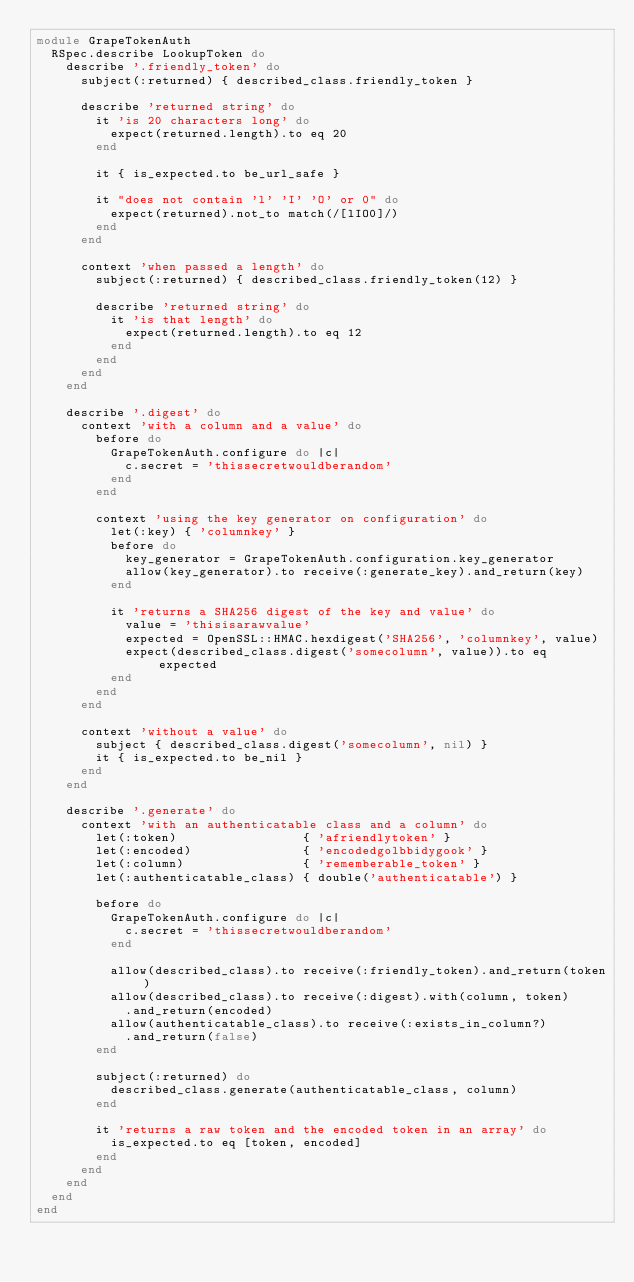Convert code to text. <code><loc_0><loc_0><loc_500><loc_500><_Ruby_>module GrapeTokenAuth
  RSpec.describe LookupToken do
    describe '.friendly_token' do
      subject(:returned) { described_class.friendly_token }

      describe 'returned string' do
        it 'is 20 characters long' do
          expect(returned.length).to eq 20
        end

        it { is_expected.to be_url_safe }

        it "does not contain 'l' 'I' 'O' or 0" do
          expect(returned).not_to match(/[lIO0]/)
        end
      end

      context 'when passed a length' do
        subject(:returned) { described_class.friendly_token(12) }

        describe 'returned string' do
          it 'is that length' do
            expect(returned.length).to eq 12
          end
        end
      end
    end

    describe '.digest' do
      context 'with a column and a value' do
        before do
          GrapeTokenAuth.configure do |c|
            c.secret = 'thissecretwouldberandom'
          end
        end

        context 'using the key generator on configuration' do
          let(:key) { 'columnkey' }
          before do
            key_generator = GrapeTokenAuth.configuration.key_generator
            allow(key_generator).to receive(:generate_key).and_return(key)
          end

          it 'returns a SHA256 digest of the key and value' do
            value = 'thisisarawvalue'
            expected = OpenSSL::HMAC.hexdigest('SHA256', 'columnkey', value)
            expect(described_class.digest('somecolumn', value)).to eq expected
          end
        end
      end

      context 'without a value' do
        subject { described_class.digest('somecolumn', nil) }
        it { is_expected.to be_nil }
      end
    end

    describe '.generate' do
      context 'with an authenticatable class and a column' do
        let(:token)                 { 'afriendlytoken' }
        let(:encoded)               { 'encodedgolbbidygook' }
        let(:column)                { 'rememberable_token' }
        let(:authenticatable_class) { double('authenticatable') }

        before do
          GrapeTokenAuth.configure do |c|
            c.secret = 'thissecretwouldberandom'
          end

          allow(described_class).to receive(:friendly_token).and_return(token)
          allow(described_class).to receive(:digest).with(column, token)
            .and_return(encoded)
          allow(authenticatable_class).to receive(:exists_in_column?)
            .and_return(false)
        end

        subject(:returned) do
          described_class.generate(authenticatable_class, column)
        end

        it 'returns a raw token and the encoded token in an array' do
          is_expected.to eq [token, encoded]
        end
      end
    end
  end
end
</code> 